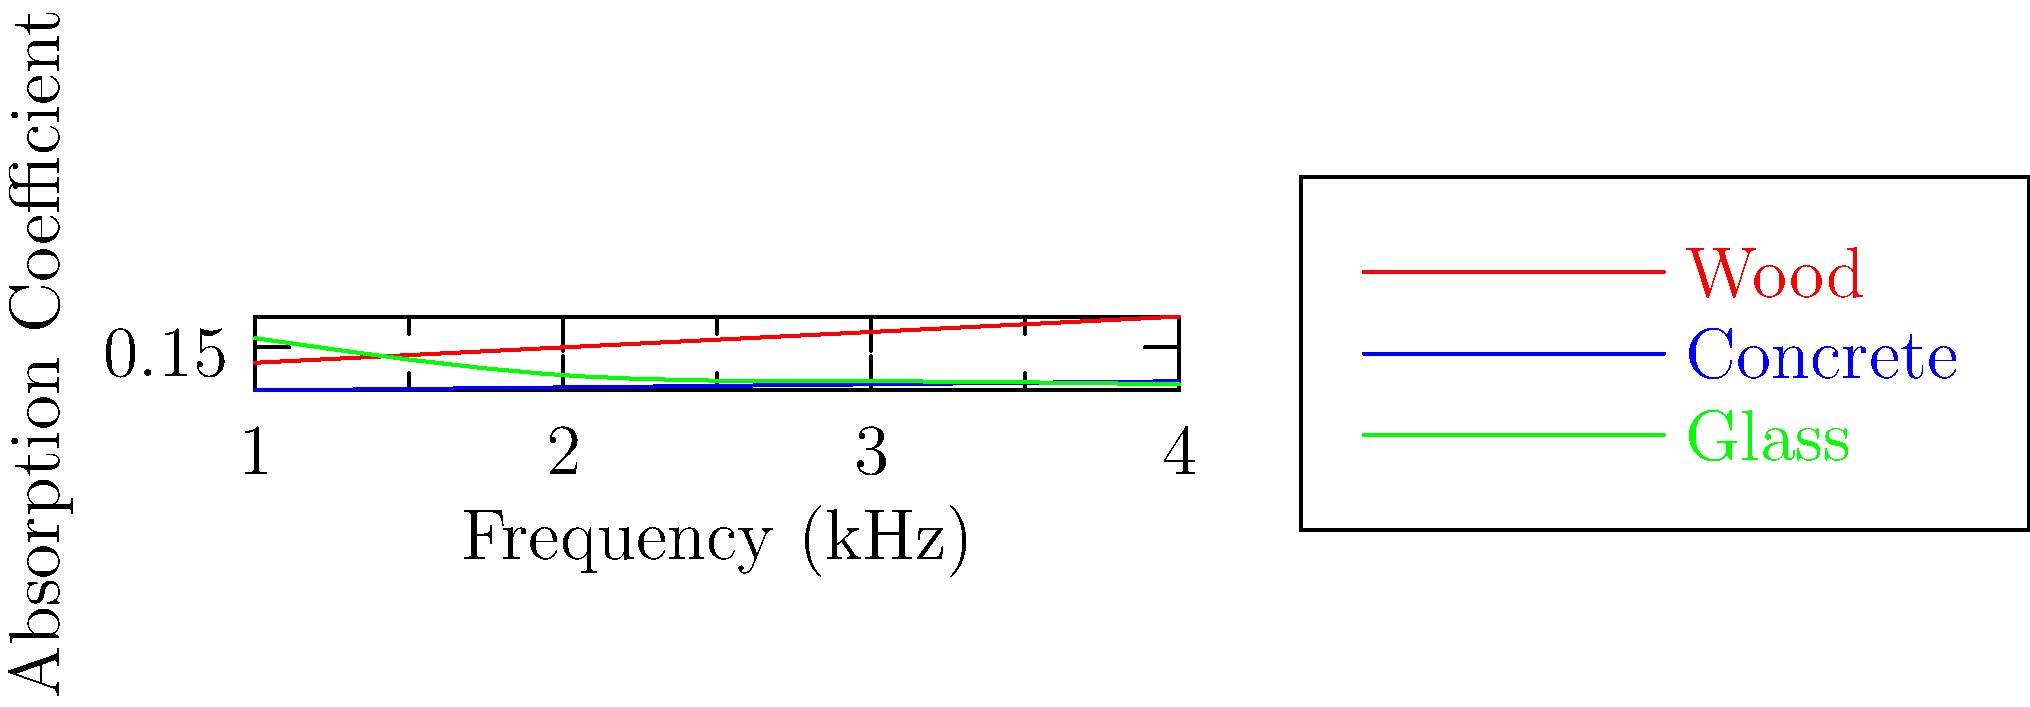In a recent copyright infringement case involving a recorded live performance, the acoustics of the concert hall have become a point of contention. Based on the graph showing absorption coefficients of different materials across various frequencies, which material would be most suitable for constructing walls in a concert hall to enhance low-frequency sound reflection? To answer this question, we need to analyze the absorption coefficients of the materials presented in the graph:

1. Understand the concept: Lower absorption coefficients indicate better sound reflection.

2. Analyze the graph:
   - Wood (red line): Absorption coefficient increases from 0.1 to 0.25 as frequency increases.
   - Concrete (blue line): Absorption coefficient remains low, increasing slightly from 0.01 to 0.04.
   - Glass (green line): Absorption coefficient decreases from 0.18 to 0.03 as frequency increases.

3. Focus on low frequencies:
   At 1 kHz (the lowest frequency shown), the absorption coefficients are:
   - Wood: ~0.1
   - Concrete: ~0.01
   - Glass: ~0.18

4. Compare the values:
   Concrete has the lowest absorption coefficient at low frequencies, meaning it will reflect more sound.

5. Consider the legal context:
   As a copyright lawyer, understanding the acoustic properties is crucial for arguing how the recording might have been affected by the concert hall's construction.
Answer: Concrete 